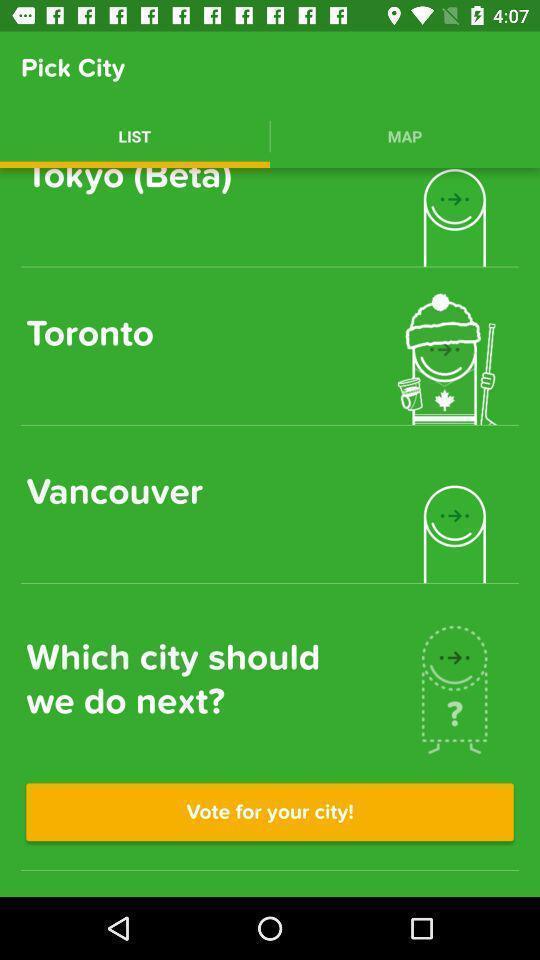Provide a description of this screenshot. Page shows to vote for your selected city. 